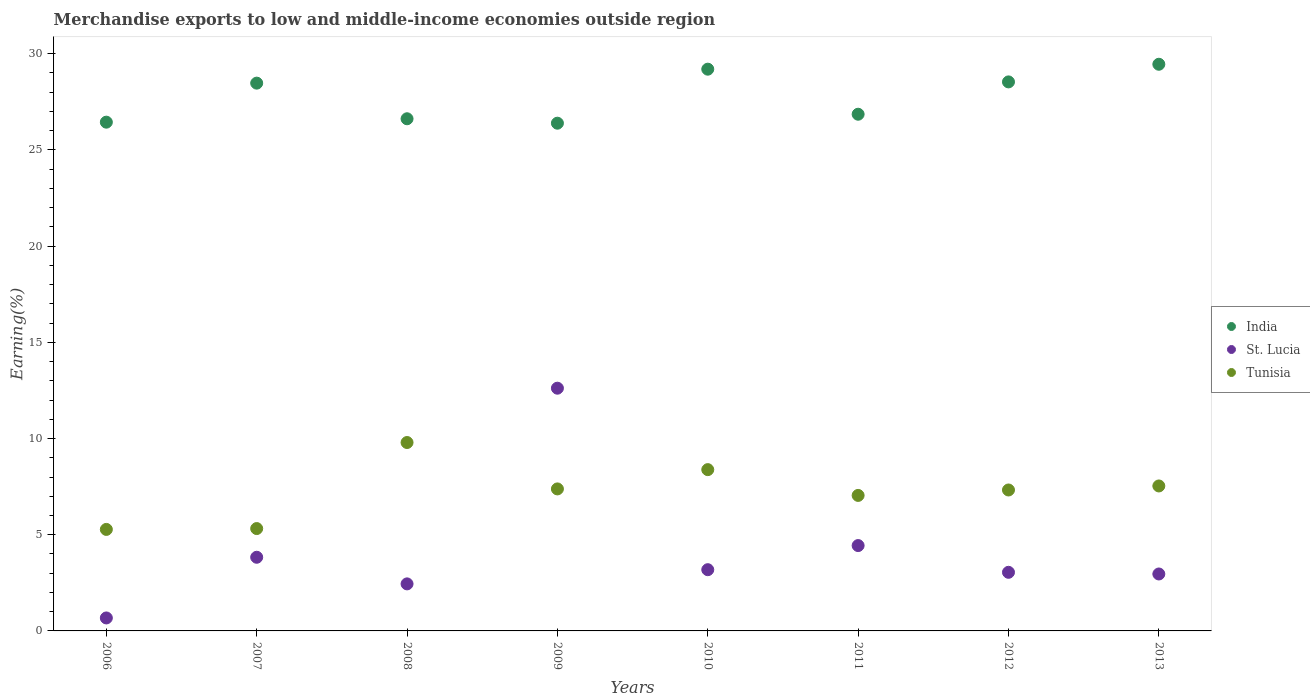Is the number of dotlines equal to the number of legend labels?
Provide a succinct answer. Yes. What is the percentage of amount earned from merchandise exports in Tunisia in 2007?
Your answer should be compact. 5.32. Across all years, what is the maximum percentage of amount earned from merchandise exports in St. Lucia?
Your answer should be very brief. 12.62. Across all years, what is the minimum percentage of amount earned from merchandise exports in St. Lucia?
Your response must be concise. 0.67. What is the total percentage of amount earned from merchandise exports in India in the graph?
Ensure brevity in your answer.  221.97. What is the difference between the percentage of amount earned from merchandise exports in St. Lucia in 2006 and that in 2009?
Give a very brief answer. -11.94. What is the difference between the percentage of amount earned from merchandise exports in Tunisia in 2007 and the percentage of amount earned from merchandise exports in St. Lucia in 2008?
Offer a terse response. 2.88. What is the average percentage of amount earned from merchandise exports in St. Lucia per year?
Your answer should be compact. 4.15. In the year 2009, what is the difference between the percentage of amount earned from merchandise exports in Tunisia and percentage of amount earned from merchandise exports in St. Lucia?
Provide a succinct answer. -5.24. What is the ratio of the percentage of amount earned from merchandise exports in Tunisia in 2012 to that in 2013?
Keep it short and to the point. 0.97. What is the difference between the highest and the second highest percentage of amount earned from merchandise exports in India?
Provide a short and direct response. 0.26. What is the difference between the highest and the lowest percentage of amount earned from merchandise exports in India?
Ensure brevity in your answer.  3.06. In how many years, is the percentage of amount earned from merchandise exports in Tunisia greater than the average percentage of amount earned from merchandise exports in Tunisia taken over all years?
Ensure brevity in your answer.  5. Is the percentage of amount earned from merchandise exports in St. Lucia strictly less than the percentage of amount earned from merchandise exports in Tunisia over the years?
Offer a very short reply. No. How many dotlines are there?
Ensure brevity in your answer.  3. What is the difference between two consecutive major ticks on the Y-axis?
Offer a very short reply. 5. Are the values on the major ticks of Y-axis written in scientific E-notation?
Ensure brevity in your answer.  No. Does the graph contain grids?
Offer a very short reply. No. Where does the legend appear in the graph?
Make the answer very short. Center right. How many legend labels are there?
Give a very brief answer. 3. How are the legend labels stacked?
Your response must be concise. Vertical. What is the title of the graph?
Your answer should be compact. Merchandise exports to low and middle-income economies outside region. What is the label or title of the Y-axis?
Your answer should be compact. Earning(%). What is the Earning(%) of India in 2006?
Give a very brief answer. 26.44. What is the Earning(%) in St. Lucia in 2006?
Offer a terse response. 0.67. What is the Earning(%) of Tunisia in 2006?
Ensure brevity in your answer.  5.28. What is the Earning(%) in India in 2007?
Provide a short and direct response. 28.47. What is the Earning(%) of St. Lucia in 2007?
Make the answer very short. 3.83. What is the Earning(%) in Tunisia in 2007?
Give a very brief answer. 5.32. What is the Earning(%) in India in 2008?
Your answer should be compact. 26.62. What is the Earning(%) in St. Lucia in 2008?
Your answer should be compact. 2.45. What is the Earning(%) of Tunisia in 2008?
Your answer should be very brief. 9.79. What is the Earning(%) in India in 2009?
Provide a succinct answer. 26.39. What is the Earning(%) of St. Lucia in 2009?
Provide a succinct answer. 12.62. What is the Earning(%) in Tunisia in 2009?
Your answer should be compact. 7.38. What is the Earning(%) of India in 2010?
Your response must be concise. 29.2. What is the Earning(%) of St. Lucia in 2010?
Your response must be concise. 3.18. What is the Earning(%) in Tunisia in 2010?
Make the answer very short. 8.38. What is the Earning(%) of India in 2011?
Your response must be concise. 26.86. What is the Earning(%) in St. Lucia in 2011?
Give a very brief answer. 4.44. What is the Earning(%) in Tunisia in 2011?
Your answer should be very brief. 7.04. What is the Earning(%) of India in 2012?
Ensure brevity in your answer.  28.54. What is the Earning(%) of St. Lucia in 2012?
Your answer should be compact. 3.05. What is the Earning(%) in Tunisia in 2012?
Your response must be concise. 7.33. What is the Earning(%) of India in 2013?
Offer a terse response. 29.45. What is the Earning(%) of St. Lucia in 2013?
Provide a succinct answer. 2.96. What is the Earning(%) of Tunisia in 2013?
Give a very brief answer. 7.53. Across all years, what is the maximum Earning(%) of India?
Your answer should be compact. 29.45. Across all years, what is the maximum Earning(%) in St. Lucia?
Keep it short and to the point. 12.62. Across all years, what is the maximum Earning(%) of Tunisia?
Your answer should be compact. 9.79. Across all years, what is the minimum Earning(%) of India?
Provide a short and direct response. 26.39. Across all years, what is the minimum Earning(%) of St. Lucia?
Give a very brief answer. 0.67. Across all years, what is the minimum Earning(%) of Tunisia?
Give a very brief answer. 5.28. What is the total Earning(%) of India in the graph?
Ensure brevity in your answer.  221.97. What is the total Earning(%) of St. Lucia in the graph?
Keep it short and to the point. 33.19. What is the total Earning(%) of Tunisia in the graph?
Give a very brief answer. 58.06. What is the difference between the Earning(%) in India in 2006 and that in 2007?
Ensure brevity in your answer.  -2.03. What is the difference between the Earning(%) of St. Lucia in 2006 and that in 2007?
Provide a short and direct response. -3.15. What is the difference between the Earning(%) in Tunisia in 2006 and that in 2007?
Offer a terse response. -0.04. What is the difference between the Earning(%) of India in 2006 and that in 2008?
Offer a very short reply. -0.18. What is the difference between the Earning(%) of St. Lucia in 2006 and that in 2008?
Offer a terse response. -1.77. What is the difference between the Earning(%) in Tunisia in 2006 and that in 2008?
Make the answer very short. -4.52. What is the difference between the Earning(%) in India in 2006 and that in 2009?
Provide a short and direct response. 0.05. What is the difference between the Earning(%) of St. Lucia in 2006 and that in 2009?
Your response must be concise. -11.94. What is the difference between the Earning(%) of Tunisia in 2006 and that in 2009?
Make the answer very short. -2.1. What is the difference between the Earning(%) of India in 2006 and that in 2010?
Provide a succinct answer. -2.75. What is the difference between the Earning(%) in St. Lucia in 2006 and that in 2010?
Your response must be concise. -2.51. What is the difference between the Earning(%) in Tunisia in 2006 and that in 2010?
Provide a succinct answer. -3.11. What is the difference between the Earning(%) of India in 2006 and that in 2011?
Your answer should be compact. -0.41. What is the difference between the Earning(%) in St. Lucia in 2006 and that in 2011?
Offer a terse response. -3.76. What is the difference between the Earning(%) in Tunisia in 2006 and that in 2011?
Keep it short and to the point. -1.77. What is the difference between the Earning(%) of India in 2006 and that in 2012?
Your response must be concise. -2.09. What is the difference between the Earning(%) of St. Lucia in 2006 and that in 2012?
Provide a succinct answer. -2.37. What is the difference between the Earning(%) in Tunisia in 2006 and that in 2012?
Give a very brief answer. -2.05. What is the difference between the Earning(%) of India in 2006 and that in 2013?
Keep it short and to the point. -3.01. What is the difference between the Earning(%) of St. Lucia in 2006 and that in 2013?
Provide a succinct answer. -2.29. What is the difference between the Earning(%) in Tunisia in 2006 and that in 2013?
Keep it short and to the point. -2.26. What is the difference between the Earning(%) of India in 2007 and that in 2008?
Give a very brief answer. 1.85. What is the difference between the Earning(%) in St. Lucia in 2007 and that in 2008?
Give a very brief answer. 1.38. What is the difference between the Earning(%) in Tunisia in 2007 and that in 2008?
Provide a succinct answer. -4.47. What is the difference between the Earning(%) of India in 2007 and that in 2009?
Give a very brief answer. 2.08. What is the difference between the Earning(%) of St. Lucia in 2007 and that in 2009?
Ensure brevity in your answer.  -8.79. What is the difference between the Earning(%) of Tunisia in 2007 and that in 2009?
Your response must be concise. -2.06. What is the difference between the Earning(%) in India in 2007 and that in 2010?
Provide a short and direct response. -0.73. What is the difference between the Earning(%) of St. Lucia in 2007 and that in 2010?
Give a very brief answer. 0.65. What is the difference between the Earning(%) of Tunisia in 2007 and that in 2010?
Ensure brevity in your answer.  -3.06. What is the difference between the Earning(%) of India in 2007 and that in 2011?
Your answer should be compact. 1.62. What is the difference between the Earning(%) of St. Lucia in 2007 and that in 2011?
Your answer should be compact. -0.61. What is the difference between the Earning(%) in Tunisia in 2007 and that in 2011?
Provide a short and direct response. -1.72. What is the difference between the Earning(%) in India in 2007 and that in 2012?
Offer a terse response. -0.06. What is the difference between the Earning(%) of St. Lucia in 2007 and that in 2012?
Ensure brevity in your answer.  0.78. What is the difference between the Earning(%) of Tunisia in 2007 and that in 2012?
Keep it short and to the point. -2.01. What is the difference between the Earning(%) of India in 2007 and that in 2013?
Provide a succinct answer. -0.98. What is the difference between the Earning(%) in St. Lucia in 2007 and that in 2013?
Ensure brevity in your answer.  0.87. What is the difference between the Earning(%) of Tunisia in 2007 and that in 2013?
Make the answer very short. -2.21. What is the difference between the Earning(%) of India in 2008 and that in 2009?
Offer a very short reply. 0.23. What is the difference between the Earning(%) in St. Lucia in 2008 and that in 2009?
Offer a very short reply. -10.17. What is the difference between the Earning(%) of Tunisia in 2008 and that in 2009?
Make the answer very short. 2.41. What is the difference between the Earning(%) in India in 2008 and that in 2010?
Offer a very short reply. -2.58. What is the difference between the Earning(%) in St. Lucia in 2008 and that in 2010?
Provide a succinct answer. -0.74. What is the difference between the Earning(%) in Tunisia in 2008 and that in 2010?
Keep it short and to the point. 1.41. What is the difference between the Earning(%) in India in 2008 and that in 2011?
Give a very brief answer. -0.24. What is the difference between the Earning(%) in St. Lucia in 2008 and that in 2011?
Give a very brief answer. -1.99. What is the difference between the Earning(%) in Tunisia in 2008 and that in 2011?
Your answer should be very brief. 2.75. What is the difference between the Earning(%) of India in 2008 and that in 2012?
Provide a short and direct response. -1.92. What is the difference between the Earning(%) in St. Lucia in 2008 and that in 2012?
Ensure brevity in your answer.  -0.6. What is the difference between the Earning(%) of Tunisia in 2008 and that in 2012?
Keep it short and to the point. 2.47. What is the difference between the Earning(%) of India in 2008 and that in 2013?
Offer a terse response. -2.83. What is the difference between the Earning(%) in St. Lucia in 2008 and that in 2013?
Provide a succinct answer. -0.51. What is the difference between the Earning(%) in Tunisia in 2008 and that in 2013?
Keep it short and to the point. 2.26. What is the difference between the Earning(%) in India in 2009 and that in 2010?
Give a very brief answer. -2.81. What is the difference between the Earning(%) of St. Lucia in 2009 and that in 2010?
Make the answer very short. 9.43. What is the difference between the Earning(%) of Tunisia in 2009 and that in 2010?
Offer a terse response. -1. What is the difference between the Earning(%) of India in 2009 and that in 2011?
Your answer should be compact. -0.47. What is the difference between the Earning(%) in St. Lucia in 2009 and that in 2011?
Your answer should be compact. 8.18. What is the difference between the Earning(%) of Tunisia in 2009 and that in 2011?
Offer a terse response. 0.34. What is the difference between the Earning(%) in India in 2009 and that in 2012?
Your response must be concise. -2.15. What is the difference between the Earning(%) in St. Lucia in 2009 and that in 2012?
Offer a terse response. 9.57. What is the difference between the Earning(%) of Tunisia in 2009 and that in 2012?
Provide a succinct answer. 0.06. What is the difference between the Earning(%) of India in 2009 and that in 2013?
Ensure brevity in your answer.  -3.06. What is the difference between the Earning(%) of St. Lucia in 2009 and that in 2013?
Give a very brief answer. 9.66. What is the difference between the Earning(%) of Tunisia in 2009 and that in 2013?
Your response must be concise. -0.15. What is the difference between the Earning(%) in India in 2010 and that in 2011?
Offer a terse response. 2.34. What is the difference between the Earning(%) of St. Lucia in 2010 and that in 2011?
Your answer should be compact. -1.25. What is the difference between the Earning(%) in Tunisia in 2010 and that in 2011?
Make the answer very short. 1.34. What is the difference between the Earning(%) in India in 2010 and that in 2012?
Offer a very short reply. 0.66. What is the difference between the Earning(%) of St. Lucia in 2010 and that in 2012?
Offer a very short reply. 0.14. What is the difference between the Earning(%) of Tunisia in 2010 and that in 2012?
Your response must be concise. 1.06. What is the difference between the Earning(%) in India in 2010 and that in 2013?
Offer a very short reply. -0.26. What is the difference between the Earning(%) of St. Lucia in 2010 and that in 2013?
Your answer should be very brief. 0.22. What is the difference between the Earning(%) in Tunisia in 2010 and that in 2013?
Give a very brief answer. 0.85. What is the difference between the Earning(%) in India in 2011 and that in 2012?
Your response must be concise. -1.68. What is the difference between the Earning(%) of St. Lucia in 2011 and that in 2012?
Provide a short and direct response. 1.39. What is the difference between the Earning(%) in Tunisia in 2011 and that in 2012?
Your answer should be compact. -0.28. What is the difference between the Earning(%) in India in 2011 and that in 2013?
Offer a very short reply. -2.6. What is the difference between the Earning(%) in St. Lucia in 2011 and that in 2013?
Make the answer very short. 1.48. What is the difference between the Earning(%) of Tunisia in 2011 and that in 2013?
Ensure brevity in your answer.  -0.49. What is the difference between the Earning(%) in India in 2012 and that in 2013?
Give a very brief answer. -0.92. What is the difference between the Earning(%) in St. Lucia in 2012 and that in 2013?
Offer a terse response. 0.09. What is the difference between the Earning(%) in Tunisia in 2012 and that in 2013?
Provide a succinct answer. -0.21. What is the difference between the Earning(%) in India in 2006 and the Earning(%) in St. Lucia in 2007?
Make the answer very short. 22.61. What is the difference between the Earning(%) of India in 2006 and the Earning(%) of Tunisia in 2007?
Provide a succinct answer. 21.12. What is the difference between the Earning(%) of St. Lucia in 2006 and the Earning(%) of Tunisia in 2007?
Your response must be concise. -4.65. What is the difference between the Earning(%) of India in 2006 and the Earning(%) of St. Lucia in 2008?
Make the answer very short. 24. What is the difference between the Earning(%) of India in 2006 and the Earning(%) of Tunisia in 2008?
Offer a terse response. 16.65. What is the difference between the Earning(%) of St. Lucia in 2006 and the Earning(%) of Tunisia in 2008?
Give a very brief answer. -9.12. What is the difference between the Earning(%) in India in 2006 and the Earning(%) in St. Lucia in 2009?
Ensure brevity in your answer.  13.83. What is the difference between the Earning(%) of India in 2006 and the Earning(%) of Tunisia in 2009?
Your response must be concise. 19.06. What is the difference between the Earning(%) of St. Lucia in 2006 and the Earning(%) of Tunisia in 2009?
Keep it short and to the point. -6.71. What is the difference between the Earning(%) of India in 2006 and the Earning(%) of St. Lucia in 2010?
Provide a succinct answer. 23.26. What is the difference between the Earning(%) in India in 2006 and the Earning(%) in Tunisia in 2010?
Your response must be concise. 18.06. What is the difference between the Earning(%) in St. Lucia in 2006 and the Earning(%) in Tunisia in 2010?
Give a very brief answer. -7.71. What is the difference between the Earning(%) in India in 2006 and the Earning(%) in St. Lucia in 2011?
Make the answer very short. 22.01. What is the difference between the Earning(%) in India in 2006 and the Earning(%) in Tunisia in 2011?
Give a very brief answer. 19.4. What is the difference between the Earning(%) of St. Lucia in 2006 and the Earning(%) of Tunisia in 2011?
Make the answer very short. -6.37. What is the difference between the Earning(%) of India in 2006 and the Earning(%) of St. Lucia in 2012?
Your answer should be very brief. 23.4. What is the difference between the Earning(%) of India in 2006 and the Earning(%) of Tunisia in 2012?
Provide a succinct answer. 19.12. What is the difference between the Earning(%) in St. Lucia in 2006 and the Earning(%) in Tunisia in 2012?
Provide a succinct answer. -6.65. What is the difference between the Earning(%) of India in 2006 and the Earning(%) of St. Lucia in 2013?
Provide a succinct answer. 23.48. What is the difference between the Earning(%) in India in 2006 and the Earning(%) in Tunisia in 2013?
Give a very brief answer. 18.91. What is the difference between the Earning(%) in St. Lucia in 2006 and the Earning(%) in Tunisia in 2013?
Your response must be concise. -6.86. What is the difference between the Earning(%) of India in 2007 and the Earning(%) of St. Lucia in 2008?
Offer a very short reply. 26.03. What is the difference between the Earning(%) in India in 2007 and the Earning(%) in Tunisia in 2008?
Keep it short and to the point. 18.68. What is the difference between the Earning(%) in St. Lucia in 2007 and the Earning(%) in Tunisia in 2008?
Make the answer very short. -5.96. What is the difference between the Earning(%) in India in 2007 and the Earning(%) in St. Lucia in 2009?
Keep it short and to the point. 15.86. What is the difference between the Earning(%) of India in 2007 and the Earning(%) of Tunisia in 2009?
Make the answer very short. 21.09. What is the difference between the Earning(%) in St. Lucia in 2007 and the Earning(%) in Tunisia in 2009?
Your answer should be compact. -3.55. What is the difference between the Earning(%) in India in 2007 and the Earning(%) in St. Lucia in 2010?
Your answer should be very brief. 25.29. What is the difference between the Earning(%) in India in 2007 and the Earning(%) in Tunisia in 2010?
Keep it short and to the point. 20.09. What is the difference between the Earning(%) of St. Lucia in 2007 and the Earning(%) of Tunisia in 2010?
Your response must be concise. -4.55. What is the difference between the Earning(%) in India in 2007 and the Earning(%) in St. Lucia in 2011?
Provide a succinct answer. 24.04. What is the difference between the Earning(%) of India in 2007 and the Earning(%) of Tunisia in 2011?
Your answer should be very brief. 21.43. What is the difference between the Earning(%) in St. Lucia in 2007 and the Earning(%) in Tunisia in 2011?
Offer a terse response. -3.21. What is the difference between the Earning(%) of India in 2007 and the Earning(%) of St. Lucia in 2012?
Offer a very short reply. 25.43. What is the difference between the Earning(%) in India in 2007 and the Earning(%) in Tunisia in 2012?
Provide a succinct answer. 21.15. What is the difference between the Earning(%) in St. Lucia in 2007 and the Earning(%) in Tunisia in 2012?
Keep it short and to the point. -3.5. What is the difference between the Earning(%) of India in 2007 and the Earning(%) of St. Lucia in 2013?
Your answer should be compact. 25.51. What is the difference between the Earning(%) in India in 2007 and the Earning(%) in Tunisia in 2013?
Your answer should be compact. 20.94. What is the difference between the Earning(%) in St. Lucia in 2007 and the Earning(%) in Tunisia in 2013?
Provide a short and direct response. -3.71. What is the difference between the Earning(%) of India in 2008 and the Earning(%) of St. Lucia in 2009?
Offer a very short reply. 14. What is the difference between the Earning(%) in India in 2008 and the Earning(%) in Tunisia in 2009?
Your response must be concise. 19.24. What is the difference between the Earning(%) of St. Lucia in 2008 and the Earning(%) of Tunisia in 2009?
Your response must be concise. -4.94. What is the difference between the Earning(%) in India in 2008 and the Earning(%) in St. Lucia in 2010?
Your response must be concise. 23.44. What is the difference between the Earning(%) of India in 2008 and the Earning(%) of Tunisia in 2010?
Provide a short and direct response. 18.24. What is the difference between the Earning(%) of St. Lucia in 2008 and the Earning(%) of Tunisia in 2010?
Offer a very short reply. -5.94. What is the difference between the Earning(%) in India in 2008 and the Earning(%) in St. Lucia in 2011?
Give a very brief answer. 22.18. What is the difference between the Earning(%) of India in 2008 and the Earning(%) of Tunisia in 2011?
Your answer should be very brief. 19.58. What is the difference between the Earning(%) of St. Lucia in 2008 and the Earning(%) of Tunisia in 2011?
Offer a very short reply. -4.6. What is the difference between the Earning(%) in India in 2008 and the Earning(%) in St. Lucia in 2012?
Provide a short and direct response. 23.57. What is the difference between the Earning(%) of India in 2008 and the Earning(%) of Tunisia in 2012?
Provide a short and direct response. 19.29. What is the difference between the Earning(%) of St. Lucia in 2008 and the Earning(%) of Tunisia in 2012?
Provide a succinct answer. -4.88. What is the difference between the Earning(%) of India in 2008 and the Earning(%) of St. Lucia in 2013?
Your response must be concise. 23.66. What is the difference between the Earning(%) in India in 2008 and the Earning(%) in Tunisia in 2013?
Provide a succinct answer. 19.09. What is the difference between the Earning(%) in St. Lucia in 2008 and the Earning(%) in Tunisia in 2013?
Make the answer very short. -5.09. What is the difference between the Earning(%) in India in 2009 and the Earning(%) in St. Lucia in 2010?
Ensure brevity in your answer.  23.21. What is the difference between the Earning(%) in India in 2009 and the Earning(%) in Tunisia in 2010?
Make the answer very short. 18.01. What is the difference between the Earning(%) in St. Lucia in 2009 and the Earning(%) in Tunisia in 2010?
Offer a terse response. 4.23. What is the difference between the Earning(%) of India in 2009 and the Earning(%) of St. Lucia in 2011?
Offer a terse response. 21.95. What is the difference between the Earning(%) in India in 2009 and the Earning(%) in Tunisia in 2011?
Keep it short and to the point. 19.35. What is the difference between the Earning(%) in St. Lucia in 2009 and the Earning(%) in Tunisia in 2011?
Your response must be concise. 5.57. What is the difference between the Earning(%) of India in 2009 and the Earning(%) of St. Lucia in 2012?
Make the answer very short. 23.34. What is the difference between the Earning(%) of India in 2009 and the Earning(%) of Tunisia in 2012?
Provide a succinct answer. 19.06. What is the difference between the Earning(%) of St. Lucia in 2009 and the Earning(%) of Tunisia in 2012?
Keep it short and to the point. 5.29. What is the difference between the Earning(%) in India in 2009 and the Earning(%) in St. Lucia in 2013?
Give a very brief answer. 23.43. What is the difference between the Earning(%) of India in 2009 and the Earning(%) of Tunisia in 2013?
Your answer should be compact. 18.86. What is the difference between the Earning(%) of St. Lucia in 2009 and the Earning(%) of Tunisia in 2013?
Provide a succinct answer. 5.08. What is the difference between the Earning(%) in India in 2010 and the Earning(%) in St. Lucia in 2011?
Keep it short and to the point. 24.76. What is the difference between the Earning(%) in India in 2010 and the Earning(%) in Tunisia in 2011?
Ensure brevity in your answer.  22.15. What is the difference between the Earning(%) of St. Lucia in 2010 and the Earning(%) of Tunisia in 2011?
Your answer should be compact. -3.86. What is the difference between the Earning(%) of India in 2010 and the Earning(%) of St. Lucia in 2012?
Provide a succinct answer. 26.15. What is the difference between the Earning(%) of India in 2010 and the Earning(%) of Tunisia in 2012?
Provide a short and direct response. 21.87. What is the difference between the Earning(%) in St. Lucia in 2010 and the Earning(%) in Tunisia in 2012?
Your response must be concise. -4.14. What is the difference between the Earning(%) in India in 2010 and the Earning(%) in St. Lucia in 2013?
Give a very brief answer. 26.24. What is the difference between the Earning(%) in India in 2010 and the Earning(%) in Tunisia in 2013?
Ensure brevity in your answer.  21.66. What is the difference between the Earning(%) in St. Lucia in 2010 and the Earning(%) in Tunisia in 2013?
Offer a very short reply. -4.35. What is the difference between the Earning(%) of India in 2011 and the Earning(%) of St. Lucia in 2012?
Provide a short and direct response. 23.81. What is the difference between the Earning(%) in India in 2011 and the Earning(%) in Tunisia in 2012?
Provide a succinct answer. 19.53. What is the difference between the Earning(%) of St. Lucia in 2011 and the Earning(%) of Tunisia in 2012?
Provide a succinct answer. -2.89. What is the difference between the Earning(%) in India in 2011 and the Earning(%) in St. Lucia in 2013?
Give a very brief answer. 23.9. What is the difference between the Earning(%) in India in 2011 and the Earning(%) in Tunisia in 2013?
Your response must be concise. 19.32. What is the difference between the Earning(%) of St. Lucia in 2011 and the Earning(%) of Tunisia in 2013?
Make the answer very short. -3.1. What is the difference between the Earning(%) in India in 2012 and the Earning(%) in St. Lucia in 2013?
Provide a succinct answer. 25.58. What is the difference between the Earning(%) in India in 2012 and the Earning(%) in Tunisia in 2013?
Offer a terse response. 21. What is the difference between the Earning(%) in St. Lucia in 2012 and the Earning(%) in Tunisia in 2013?
Make the answer very short. -4.49. What is the average Earning(%) in India per year?
Keep it short and to the point. 27.75. What is the average Earning(%) of St. Lucia per year?
Offer a very short reply. 4.15. What is the average Earning(%) in Tunisia per year?
Make the answer very short. 7.26. In the year 2006, what is the difference between the Earning(%) of India and Earning(%) of St. Lucia?
Provide a short and direct response. 25.77. In the year 2006, what is the difference between the Earning(%) in India and Earning(%) in Tunisia?
Offer a terse response. 21.17. In the year 2006, what is the difference between the Earning(%) of St. Lucia and Earning(%) of Tunisia?
Make the answer very short. -4.6. In the year 2007, what is the difference between the Earning(%) of India and Earning(%) of St. Lucia?
Provide a succinct answer. 24.64. In the year 2007, what is the difference between the Earning(%) in India and Earning(%) in Tunisia?
Your answer should be compact. 23.15. In the year 2007, what is the difference between the Earning(%) of St. Lucia and Earning(%) of Tunisia?
Provide a succinct answer. -1.49. In the year 2008, what is the difference between the Earning(%) in India and Earning(%) in St. Lucia?
Provide a succinct answer. 24.18. In the year 2008, what is the difference between the Earning(%) of India and Earning(%) of Tunisia?
Offer a terse response. 16.83. In the year 2008, what is the difference between the Earning(%) in St. Lucia and Earning(%) in Tunisia?
Your answer should be compact. -7.35. In the year 2009, what is the difference between the Earning(%) of India and Earning(%) of St. Lucia?
Make the answer very short. 13.77. In the year 2009, what is the difference between the Earning(%) in India and Earning(%) in Tunisia?
Your answer should be very brief. 19.01. In the year 2009, what is the difference between the Earning(%) of St. Lucia and Earning(%) of Tunisia?
Your answer should be very brief. 5.24. In the year 2010, what is the difference between the Earning(%) in India and Earning(%) in St. Lucia?
Provide a short and direct response. 26.01. In the year 2010, what is the difference between the Earning(%) in India and Earning(%) in Tunisia?
Give a very brief answer. 20.81. In the year 2010, what is the difference between the Earning(%) of St. Lucia and Earning(%) of Tunisia?
Provide a short and direct response. -5.2. In the year 2011, what is the difference between the Earning(%) in India and Earning(%) in St. Lucia?
Make the answer very short. 22.42. In the year 2011, what is the difference between the Earning(%) in India and Earning(%) in Tunisia?
Provide a short and direct response. 19.81. In the year 2011, what is the difference between the Earning(%) in St. Lucia and Earning(%) in Tunisia?
Ensure brevity in your answer.  -2.61. In the year 2012, what is the difference between the Earning(%) in India and Earning(%) in St. Lucia?
Provide a succinct answer. 25.49. In the year 2012, what is the difference between the Earning(%) in India and Earning(%) in Tunisia?
Offer a very short reply. 21.21. In the year 2012, what is the difference between the Earning(%) of St. Lucia and Earning(%) of Tunisia?
Offer a very short reply. -4.28. In the year 2013, what is the difference between the Earning(%) in India and Earning(%) in St. Lucia?
Give a very brief answer. 26.49. In the year 2013, what is the difference between the Earning(%) in India and Earning(%) in Tunisia?
Make the answer very short. 21.92. In the year 2013, what is the difference between the Earning(%) of St. Lucia and Earning(%) of Tunisia?
Make the answer very short. -4.58. What is the ratio of the Earning(%) in India in 2006 to that in 2007?
Your response must be concise. 0.93. What is the ratio of the Earning(%) of St. Lucia in 2006 to that in 2007?
Give a very brief answer. 0.18. What is the ratio of the Earning(%) in St. Lucia in 2006 to that in 2008?
Ensure brevity in your answer.  0.28. What is the ratio of the Earning(%) in Tunisia in 2006 to that in 2008?
Your response must be concise. 0.54. What is the ratio of the Earning(%) of St. Lucia in 2006 to that in 2009?
Make the answer very short. 0.05. What is the ratio of the Earning(%) in Tunisia in 2006 to that in 2009?
Your response must be concise. 0.71. What is the ratio of the Earning(%) in India in 2006 to that in 2010?
Your response must be concise. 0.91. What is the ratio of the Earning(%) in St. Lucia in 2006 to that in 2010?
Give a very brief answer. 0.21. What is the ratio of the Earning(%) of Tunisia in 2006 to that in 2010?
Offer a terse response. 0.63. What is the ratio of the Earning(%) of India in 2006 to that in 2011?
Your answer should be very brief. 0.98. What is the ratio of the Earning(%) of St. Lucia in 2006 to that in 2011?
Keep it short and to the point. 0.15. What is the ratio of the Earning(%) in Tunisia in 2006 to that in 2011?
Ensure brevity in your answer.  0.75. What is the ratio of the Earning(%) in India in 2006 to that in 2012?
Your response must be concise. 0.93. What is the ratio of the Earning(%) in St. Lucia in 2006 to that in 2012?
Your response must be concise. 0.22. What is the ratio of the Earning(%) of Tunisia in 2006 to that in 2012?
Make the answer very short. 0.72. What is the ratio of the Earning(%) of India in 2006 to that in 2013?
Keep it short and to the point. 0.9. What is the ratio of the Earning(%) of St. Lucia in 2006 to that in 2013?
Your answer should be very brief. 0.23. What is the ratio of the Earning(%) of Tunisia in 2006 to that in 2013?
Make the answer very short. 0.7. What is the ratio of the Earning(%) in India in 2007 to that in 2008?
Make the answer very short. 1.07. What is the ratio of the Earning(%) in St. Lucia in 2007 to that in 2008?
Ensure brevity in your answer.  1.57. What is the ratio of the Earning(%) of Tunisia in 2007 to that in 2008?
Provide a succinct answer. 0.54. What is the ratio of the Earning(%) in India in 2007 to that in 2009?
Your answer should be compact. 1.08. What is the ratio of the Earning(%) in St. Lucia in 2007 to that in 2009?
Provide a succinct answer. 0.3. What is the ratio of the Earning(%) of Tunisia in 2007 to that in 2009?
Keep it short and to the point. 0.72. What is the ratio of the Earning(%) in India in 2007 to that in 2010?
Offer a terse response. 0.98. What is the ratio of the Earning(%) in St. Lucia in 2007 to that in 2010?
Make the answer very short. 1.2. What is the ratio of the Earning(%) in Tunisia in 2007 to that in 2010?
Your response must be concise. 0.63. What is the ratio of the Earning(%) of India in 2007 to that in 2011?
Offer a very short reply. 1.06. What is the ratio of the Earning(%) of St. Lucia in 2007 to that in 2011?
Your answer should be very brief. 0.86. What is the ratio of the Earning(%) of Tunisia in 2007 to that in 2011?
Ensure brevity in your answer.  0.76. What is the ratio of the Earning(%) in India in 2007 to that in 2012?
Your answer should be compact. 1. What is the ratio of the Earning(%) of St. Lucia in 2007 to that in 2012?
Offer a very short reply. 1.26. What is the ratio of the Earning(%) of Tunisia in 2007 to that in 2012?
Give a very brief answer. 0.73. What is the ratio of the Earning(%) in India in 2007 to that in 2013?
Provide a succinct answer. 0.97. What is the ratio of the Earning(%) in St. Lucia in 2007 to that in 2013?
Offer a very short reply. 1.29. What is the ratio of the Earning(%) of Tunisia in 2007 to that in 2013?
Give a very brief answer. 0.71. What is the ratio of the Earning(%) of India in 2008 to that in 2009?
Your answer should be very brief. 1.01. What is the ratio of the Earning(%) of St. Lucia in 2008 to that in 2009?
Provide a succinct answer. 0.19. What is the ratio of the Earning(%) in Tunisia in 2008 to that in 2009?
Your answer should be compact. 1.33. What is the ratio of the Earning(%) of India in 2008 to that in 2010?
Your answer should be very brief. 0.91. What is the ratio of the Earning(%) of St. Lucia in 2008 to that in 2010?
Provide a short and direct response. 0.77. What is the ratio of the Earning(%) of Tunisia in 2008 to that in 2010?
Give a very brief answer. 1.17. What is the ratio of the Earning(%) in St. Lucia in 2008 to that in 2011?
Keep it short and to the point. 0.55. What is the ratio of the Earning(%) in Tunisia in 2008 to that in 2011?
Provide a succinct answer. 1.39. What is the ratio of the Earning(%) in India in 2008 to that in 2012?
Provide a succinct answer. 0.93. What is the ratio of the Earning(%) in St. Lucia in 2008 to that in 2012?
Provide a short and direct response. 0.8. What is the ratio of the Earning(%) in Tunisia in 2008 to that in 2012?
Your answer should be very brief. 1.34. What is the ratio of the Earning(%) in India in 2008 to that in 2013?
Keep it short and to the point. 0.9. What is the ratio of the Earning(%) in St. Lucia in 2008 to that in 2013?
Your response must be concise. 0.83. What is the ratio of the Earning(%) in Tunisia in 2008 to that in 2013?
Keep it short and to the point. 1.3. What is the ratio of the Earning(%) in India in 2009 to that in 2010?
Offer a terse response. 0.9. What is the ratio of the Earning(%) of St. Lucia in 2009 to that in 2010?
Your response must be concise. 3.96. What is the ratio of the Earning(%) in Tunisia in 2009 to that in 2010?
Offer a terse response. 0.88. What is the ratio of the Earning(%) of India in 2009 to that in 2011?
Your answer should be very brief. 0.98. What is the ratio of the Earning(%) in St. Lucia in 2009 to that in 2011?
Your response must be concise. 2.84. What is the ratio of the Earning(%) of Tunisia in 2009 to that in 2011?
Your response must be concise. 1.05. What is the ratio of the Earning(%) in India in 2009 to that in 2012?
Your answer should be compact. 0.92. What is the ratio of the Earning(%) of St. Lucia in 2009 to that in 2012?
Your response must be concise. 4.14. What is the ratio of the Earning(%) of Tunisia in 2009 to that in 2012?
Ensure brevity in your answer.  1.01. What is the ratio of the Earning(%) in India in 2009 to that in 2013?
Ensure brevity in your answer.  0.9. What is the ratio of the Earning(%) in St. Lucia in 2009 to that in 2013?
Ensure brevity in your answer.  4.26. What is the ratio of the Earning(%) in Tunisia in 2009 to that in 2013?
Provide a short and direct response. 0.98. What is the ratio of the Earning(%) of India in 2010 to that in 2011?
Ensure brevity in your answer.  1.09. What is the ratio of the Earning(%) of St. Lucia in 2010 to that in 2011?
Provide a short and direct response. 0.72. What is the ratio of the Earning(%) of Tunisia in 2010 to that in 2011?
Your answer should be compact. 1.19. What is the ratio of the Earning(%) in India in 2010 to that in 2012?
Your response must be concise. 1.02. What is the ratio of the Earning(%) in St. Lucia in 2010 to that in 2012?
Give a very brief answer. 1.04. What is the ratio of the Earning(%) of Tunisia in 2010 to that in 2012?
Provide a short and direct response. 1.14. What is the ratio of the Earning(%) in St. Lucia in 2010 to that in 2013?
Ensure brevity in your answer.  1.08. What is the ratio of the Earning(%) of Tunisia in 2010 to that in 2013?
Offer a very short reply. 1.11. What is the ratio of the Earning(%) of India in 2011 to that in 2012?
Ensure brevity in your answer.  0.94. What is the ratio of the Earning(%) of St. Lucia in 2011 to that in 2012?
Your answer should be compact. 1.46. What is the ratio of the Earning(%) of Tunisia in 2011 to that in 2012?
Ensure brevity in your answer.  0.96. What is the ratio of the Earning(%) of India in 2011 to that in 2013?
Ensure brevity in your answer.  0.91. What is the ratio of the Earning(%) in St. Lucia in 2011 to that in 2013?
Keep it short and to the point. 1.5. What is the ratio of the Earning(%) of Tunisia in 2011 to that in 2013?
Offer a terse response. 0.93. What is the ratio of the Earning(%) in India in 2012 to that in 2013?
Offer a terse response. 0.97. What is the ratio of the Earning(%) in St. Lucia in 2012 to that in 2013?
Your answer should be compact. 1.03. What is the ratio of the Earning(%) in Tunisia in 2012 to that in 2013?
Provide a short and direct response. 0.97. What is the difference between the highest and the second highest Earning(%) in India?
Provide a short and direct response. 0.26. What is the difference between the highest and the second highest Earning(%) in St. Lucia?
Give a very brief answer. 8.18. What is the difference between the highest and the second highest Earning(%) of Tunisia?
Ensure brevity in your answer.  1.41. What is the difference between the highest and the lowest Earning(%) of India?
Your answer should be compact. 3.06. What is the difference between the highest and the lowest Earning(%) in St. Lucia?
Give a very brief answer. 11.94. What is the difference between the highest and the lowest Earning(%) of Tunisia?
Offer a terse response. 4.52. 